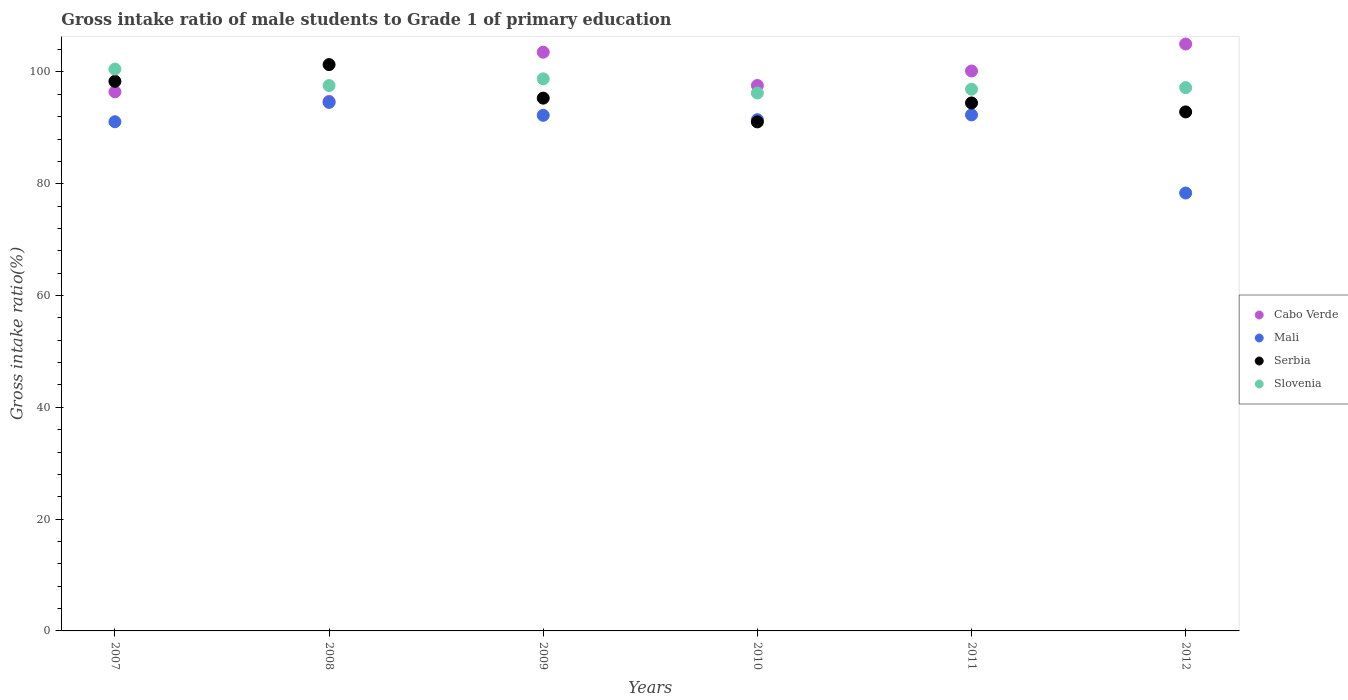How many different coloured dotlines are there?
Provide a short and direct response. 4. What is the gross intake ratio in Slovenia in 2012?
Your answer should be very brief. 97.2. Across all years, what is the maximum gross intake ratio in Slovenia?
Keep it short and to the point. 100.52. Across all years, what is the minimum gross intake ratio in Cabo Verde?
Provide a succinct answer. 94.73. In which year was the gross intake ratio in Serbia minimum?
Offer a terse response. 2010. What is the total gross intake ratio in Cabo Verde in the graph?
Offer a terse response. 597.49. What is the difference between the gross intake ratio in Mali in 2010 and that in 2012?
Ensure brevity in your answer.  13.12. What is the difference between the gross intake ratio in Serbia in 2008 and the gross intake ratio in Cabo Verde in 2010?
Keep it short and to the point. 3.73. What is the average gross intake ratio in Serbia per year?
Keep it short and to the point. 95.56. In the year 2011, what is the difference between the gross intake ratio in Mali and gross intake ratio in Cabo Verde?
Your answer should be very brief. -7.86. What is the ratio of the gross intake ratio in Cabo Verde in 2010 to that in 2011?
Ensure brevity in your answer.  0.97. Is the gross intake ratio in Slovenia in 2010 less than that in 2011?
Make the answer very short. Yes. Is the difference between the gross intake ratio in Mali in 2008 and 2012 greater than the difference between the gross intake ratio in Cabo Verde in 2008 and 2012?
Your answer should be very brief. Yes. What is the difference between the highest and the second highest gross intake ratio in Mali?
Provide a succinct answer. 2.24. What is the difference between the highest and the lowest gross intake ratio in Serbia?
Give a very brief answer. 10.25. In how many years, is the gross intake ratio in Slovenia greater than the average gross intake ratio in Slovenia taken over all years?
Your answer should be compact. 2. Is the sum of the gross intake ratio in Cabo Verde in 2007 and 2009 greater than the maximum gross intake ratio in Mali across all years?
Offer a terse response. Yes. Is it the case that in every year, the sum of the gross intake ratio in Serbia and gross intake ratio in Slovenia  is greater than the sum of gross intake ratio in Mali and gross intake ratio in Cabo Verde?
Keep it short and to the point. No. Is the gross intake ratio in Serbia strictly greater than the gross intake ratio in Cabo Verde over the years?
Provide a succinct answer. No. How many years are there in the graph?
Provide a short and direct response. 6. Are the values on the major ticks of Y-axis written in scientific E-notation?
Your answer should be compact. No. Does the graph contain any zero values?
Your answer should be very brief. No. Does the graph contain grids?
Your answer should be compact. No. Where does the legend appear in the graph?
Keep it short and to the point. Center right. How many legend labels are there?
Your answer should be compact. 4. What is the title of the graph?
Your answer should be compact. Gross intake ratio of male students to Grade 1 of primary education. Does "Upper middle income" appear as one of the legend labels in the graph?
Offer a terse response. No. What is the label or title of the X-axis?
Provide a short and direct response. Years. What is the label or title of the Y-axis?
Give a very brief answer. Gross intake ratio(%). What is the Gross intake ratio(%) of Cabo Verde in 2007?
Keep it short and to the point. 96.45. What is the Gross intake ratio(%) of Mali in 2007?
Ensure brevity in your answer.  91.1. What is the Gross intake ratio(%) of Serbia in 2007?
Provide a succinct answer. 98.33. What is the Gross intake ratio(%) of Slovenia in 2007?
Provide a succinct answer. 100.52. What is the Gross intake ratio(%) of Cabo Verde in 2008?
Provide a short and direct response. 94.73. What is the Gross intake ratio(%) in Mali in 2008?
Keep it short and to the point. 94.56. What is the Gross intake ratio(%) in Serbia in 2008?
Provide a succinct answer. 101.32. What is the Gross intake ratio(%) of Slovenia in 2008?
Your answer should be very brief. 97.57. What is the Gross intake ratio(%) in Cabo Verde in 2009?
Provide a short and direct response. 103.54. What is the Gross intake ratio(%) of Mali in 2009?
Offer a terse response. 92.24. What is the Gross intake ratio(%) of Serbia in 2009?
Keep it short and to the point. 95.32. What is the Gross intake ratio(%) of Slovenia in 2009?
Make the answer very short. 98.77. What is the Gross intake ratio(%) in Cabo Verde in 2010?
Offer a terse response. 97.59. What is the Gross intake ratio(%) of Mali in 2010?
Keep it short and to the point. 91.46. What is the Gross intake ratio(%) of Serbia in 2010?
Ensure brevity in your answer.  91.07. What is the Gross intake ratio(%) of Slovenia in 2010?
Give a very brief answer. 96.25. What is the Gross intake ratio(%) of Cabo Verde in 2011?
Ensure brevity in your answer.  100.18. What is the Gross intake ratio(%) of Mali in 2011?
Ensure brevity in your answer.  92.32. What is the Gross intake ratio(%) in Serbia in 2011?
Keep it short and to the point. 94.46. What is the Gross intake ratio(%) in Slovenia in 2011?
Make the answer very short. 96.91. What is the Gross intake ratio(%) in Cabo Verde in 2012?
Provide a short and direct response. 105. What is the Gross intake ratio(%) in Mali in 2012?
Give a very brief answer. 78.35. What is the Gross intake ratio(%) of Serbia in 2012?
Ensure brevity in your answer.  92.86. What is the Gross intake ratio(%) of Slovenia in 2012?
Offer a terse response. 97.2. Across all years, what is the maximum Gross intake ratio(%) of Cabo Verde?
Your response must be concise. 105. Across all years, what is the maximum Gross intake ratio(%) of Mali?
Keep it short and to the point. 94.56. Across all years, what is the maximum Gross intake ratio(%) of Serbia?
Offer a terse response. 101.32. Across all years, what is the maximum Gross intake ratio(%) in Slovenia?
Keep it short and to the point. 100.52. Across all years, what is the minimum Gross intake ratio(%) of Cabo Verde?
Provide a succinct answer. 94.73. Across all years, what is the minimum Gross intake ratio(%) in Mali?
Provide a short and direct response. 78.35. Across all years, what is the minimum Gross intake ratio(%) in Serbia?
Ensure brevity in your answer.  91.07. Across all years, what is the minimum Gross intake ratio(%) in Slovenia?
Your answer should be compact. 96.25. What is the total Gross intake ratio(%) in Cabo Verde in the graph?
Your answer should be compact. 597.49. What is the total Gross intake ratio(%) of Mali in the graph?
Provide a succinct answer. 540.04. What is the total Gross intake ratio(%) in Serbia in the graph?
Provide a succinct answer. 573.36. What is the total Gross intake ratio(%) of Slovenia in the graph?
Make the answer very short. 587.23. What is the difference between the Gross intake ratio(%) of Cabo Verde in 2007 and that in 2008?
Your answer should be very brief. 1.71. What is the difference between the Gross intake ratio(%) of Mali in 2007 and that in 2008?
Your answer should be compact. -3.46. What is the difference between the Gross intake ratio(%) in Serbia in 2007 and that in 2008?
Offer a terse response. -2.99. What is the difference between the Gross intake ratio(%) in Slovenia in 2007 and that in 2008?
Provide a short and direct response. 2.95. What is the difference between the Gross intake ratio(%) of Cabo Verde in 2007 and that in 2009?
Your answer should be compact. -7.09. What is the difference between the Gross intake ratio(%) of Mali in 2007 and that in 2009?
Your answer should be very brief. -1.14. What is the difference between the Gross intake ratio(%) in Serbia in 2007 and that in 2009?
Offer a very short reply. 3.01. What is the difference between the Gross intake ratio(%) of Slovenia in 2007 and that in 2009?
Keep it short and to the point. 1.74. What is the difference between the Gross intake ratio(%) in Cabo Verde in 2007 and that in 2010?
Provide a short and direct response. -1.14. What is the difference between the Gross intake ratio(%) of Mali in 2007 and that in 2010?
Ensure brevity in your answer.  -0.36. What is the difference between the Gross intake ratio(%) of Serbia in 2007 and that in 2010?
Offer a very short reply. 7.26. What is the difference between the Gross intake ratio(%) of Slovenia in 2007 and that in 2010?
Keep it short and to the point. 4.27. What is the difference between the Gross intake ratio(%) of Cabo Verde in 2007 and that in 2011?
Your response must be concise. -3.73. What is the difference between the Gross intake ratio(%) in Mali in 2007 and that in 2011?
Your answer should be very brief. -1.22. What is the difference between the Gross intake ratio(%) in Serbia in 2007 and that in 2011?
Your answer should be compact. 3.87. What is the difference between the Gross intake ratio(%) in Slovenia in 2007 and that in 2011?
Provide a short and direct response. 3.6. What is the difference between the Gross intake ratio(%) of Cabo Verde in 2007 and that in 2012?
Your answer should be compact. -8.55. What is the difference between the Gross intake ratio(%) in Mali in 2007 and that in 2012?
Provide a short and direct response. 12.75. What is the difference between the Gross intake ratio(%) of Serbia in 2007 and that in 2012?
Your response must be concise. 5.47. What is the difference between the Gross intake ratio(%) of Slovenia in 2007 and that in 2012?
Provide a succinct answer. 3.32. What is the difference between the Gross intake ratio(%) of Cabo Verde in 2008 and that in 2009?
Make the answer very short. -8.8. What is the difference between the Gross intake ratio(%) in Mali in 2008 and that in 2009?
Your answer should be very brief. 2.32. What is the difference between the Gross intake ratio(%) of Serbia in 2008 and that in 2009?
Provide a short and direct response. 6. What is the difference between the Gross intake ratio(%) in Slovenia in 2008 and that in 2009?
Ensure brevity in your answer.  -1.2. What is the difference between the Gross intake ratio(%) of Cabo Verde in 2008 and that in 2010?
Offer a terse response. -2.85. What is the difference between the Gross intake ratio(%) in Mali in 2008 and that in 2010?
Your answer should be very brief. 3.1. What is the difference between the Gross intake ratio(%) of Serbia in 2008 and that in 2010?
Your answer should be compact. 10.25. What is the difference between the Gross intake ratio(%) in Slovenia in 2008 and that in 2010?
Give a very brief answer. 1.32. What is the difference between the Gross intake ratio(%) of Cabo Verde in 2008 and that in 2011?
Offer a terse response. -5.45. What is the difference between the Gross intake ratio(%) of Mali in 2008 and that in 2011?
Ensure brevity in your answer.  2.24. What is the difference between the Gross intake ratio(%) in Serbia in 2008 and that in 2011?
Your answer should be compact. 6.86. What is the difference between the Gross intake ratio(%) of Slovenia in 2008 and that in 2011?
Make the answer very short. 0.66. What is the difference between the Gross intake ratio(%) of Cabo Verde in 2008 and that in 2012?
Your response must be concise. -10.27. What is the difference between the Gross intake ratio(%) of Mali in 2008 and that in 2012?
Your answer should be very brief. 16.21. What is the difference between the Gross intake ratio(%) of Serbia in 2008 and that in 2012?
Provide a succinct answer. 8.46. What is the difference between the Gross intake ratio(%) of Slovenia in 2008 and that in 2012?
Keep it short and to the point. 0.37. What is the difference between the Gross intake ratio(%) in Cabo Verde in 2009 and that in 2010?
Offer a very short reply. 5.95. What is the difference between the Gross intake ratio(%) in Mali in 2009 and that in 2010?
Your answer should be compact. 0.78. What is the difference between the Gross intake ratio(%) in Serbia in 2009 and that in 2010?
Provide a short and direct response. 4.25. What is the difference between the Gross intake ratio(%) in Slovenia in 2009 and that in 2010?
Provide a short and direct response. 2.53. What is the difference between the Gross intake ratio(%) of Cabo Verde in 2009 and that in 2011?
Give a very brief answer. 3.36. What is the difference between the Gross intake ratio(%) in Mali in 2009 and that in 2011?
Offer a terse response. -0.08. What is the difference between the Gross intake ratio(%) of Serbia in 2009 and that in 2011?
Provide a short and direct response. 0.86. What is the difference between the Gross intake ratio(%) of Slovenia in 2009 and that in 2011?
Give a very brief answer. 1.86. What is the difference between the Gross intake ratio(%) of Cabo Verde in 2009 and that in 2012?
Offer a very short reply. -1.47. What is the difference between the Gross intake ratio(%) in Mali in 2009 and that in 2012?
Make the answer very short. 13.9. What is the difference between the Gross intake ratio(%) of Serbia in 2009 and that in 2012?
Keep it short and to the point. 2.46. What is the difference between the Gross intake ratio(%) of Slovenia in 2009 and that in 2012?
Provide a short and direct response. 1.57. What is the difference between the Gross intake ratio(%) of Cabo Verde in 2010 and that in 2011?
Provide a succinct answer. -2.59. What is the difference between the Gross intake ratio(%) in Mali in 2010 and that in 2011?
Your answer should be compact. -0.86. What is the difference between the Gross intake ratio(%) in Serbia in 2010 and that in 2011?
Make the answer very short. -3.39. What is the difference between the Gross intake ratio(%) of Slovenia in 2010 and that in 2011?
Give a very brief answer. -0.67. What is the difference between the Gross intake ratio(%) of Cabo Verde in 2010 and that in 2012?
Provide a succinct answer. -7.42. What is the difference between the Gross intake ratio(%) of Mali in 2010 and that in 2012?
Your response must be concise. 13.12. What is the difference between the Gross intake ratio(%) of Serbia in 2010 and that in 2012?
Your answer should be compact. -1.79. What is the difference between the Gross intake ratio(%) of Slovenia in 2010 and that in 2012?
Your answer should be compact. -0.95. What is the difference between the Gross intake ratio(%) in Cabo Verde in 2011 and that in 2012?
Offer a terse response. -4.82. What is the difference between the Gross intake ratio(%) in Mali in 2011 and that in 2012?
Your answer should be compact. 13.98. What is the difference between the Gross intake ratio(%) in Serbia in 2011 and that in 2012?
Offer a very short reply. 1.6. What is the difference between the Gross intake ratio(%) of Slovenia in 2011 and that in 2012?
Your answer should be compact. -0.29. What is the difference between the Gross intake ratio(%) of Cabo Verde in 2007 and the Gross intake ratio(%) of Mali in 2008?
Keep it short and to the point. 1.89. What is the difference between the Gross intake ratio(%) in Cabo Verde in 2007 and the Gross intake ratio(%) in Serbia in 2008?
Give a very brief answer. -4.87. What is the difference between the Gross intake ratio(%) in Cabo Verde in 2007 and the Gross intake ratio(%) in Slovenia in 2008?
Provide a succinct answer. -1.12. What is the difference between the Gross intake ratio(%) of Mali in 2007 and the Gross intake ratio(%) of Serbia in 2008?
Make the answer very short. -10.22. What is the difference between the Gross intake ratio(%) of Mali in 2007 and the Gross intake ratio(%) of Slovenia in 2008?
Give a very brief answer. -6.47. What is the difference between the Gross intake ratio(%) of Serbia in 2007 and the Gross intake ratio(%) of Slovenia in 2008?
Give a very brief answer. 0.76. What is the difference between the Gross intake ratio(%) in Cabo Verde in 2007 and the Gross intake ratio(%) in Mali in 2009?
Keep it short and to the point. 4.2. What is the difference between the Gross intake ratio(%) of Cabo Verde in 2007 and the Gross intake ratio(%) of Serbia in 2009?
Ensure brevity in your answer.  1.13. What is the difference between the Gross intake ratio(%) of Cabo Verde in 2007 and the Gross intake ratio(%) of Slovenia in 2009?
Make the answer very short. -2.33. What is the difference between the Gross intake ratio(%) in Mali in 2007 and the Gross intake ratio(%) in Serbia in 2009?
Offer a very short reply. -4.22. What is the difference between the Gross intake ratio(%) in Mali in 2007 and the Gross intake ratio(%) in Slovenia in 2009?
Ensure brevity in your answer.  -7.67. What is the difference between the Gross intake ratio(%) of Serbia in 2007 and the Gross intake ratio(%) of Slovenia in 2009?
Offer a very short reply. -0.45. What is the difference between the Gross intake ratio(%) of Cabo Verde in 2007 and the Gross intake ratio(%) of Mali in 2010?
Keep it short and to the point. 4.99. What is the difference between the Gross intake ratio(%) in Cabo Verde in 2007 and the Gross intake ratio(%) in Serbia in 2010?
Your answer should be compact. 5.38. What is the difference between the Gross intake ratio(%) in Cabo Verde in 2007 and the Gross intake ratio(%) in Slovenia in 2010?
Your response must be concise. 0.2. What is the difference between the Gross intake ratio(%) in Mali in 2007 and the Gross intake ratio(%) in Serbia in 2010?
Your answer should be very brief. 0.03. What is the difference between the Gross intake ratio(%) of Mali in 2007 and the Gross intake ratio(%) of Slovenia in 2010?
Your answer should be compact. -5.15. What is the difference between the Gross intake ratio(%) in Serbia in 2007 and the Gross intake ratio(%) in Slovenia in 2010?
Keep it short and to the point. 2.08. What is the difference between the Gross intake ratio(%) of Cabo Verde in 2007 and the Gross intake ratio(%) of Mali in 2011?
Your response must be concise. 4.12. What is the difference between the Gross intake ratio(%) in Cabo Verde in 2007 and the Gross intake ratio(%) in Serbia in 2011?
Your answer should be compact. 1.99. What is the difference between the Gross intake ratio(%) in Cabo Verde in 2007 and the Gross intake ratio(%) in Slovenia in 2011?
Your answer should be compact. -0.47. What is the difference between the Gross intake ratio(%) in Mali in 2007 and the Gross intake ratio(%) in Serbia in 2011?
Give a very brief answer. -3.36. What is the difference between the Gross intake ratio(%) of Mali in 2007 and the Gross intake ratio(%) of Slovenia in 2011?
Your response must be concise. -5.81. What is the difference between the Gross intake ratio(%) in Serbia in 2007 and the Gross intake ratio(%) in Slovenia in 2011?
Your answer should be compact. 1.41. What is the difference between the Gross intake ratio(%) of Cabo Verde in 2007 and the Gross intake ratio(%) of Mali in 2012?
Provide a succinct answer. 18.1. What is the difference between the Gross intake ratio(%) of Cabo Verde in 2007 and the Gross intake ratio(%) of Serbia in 2012?
Give a very brief answer. 3.59. What is the difference between the Gross intake ratio(%) in Cabo Verde in 2007 and the Gross intake ratio(%) in Slovenia in 2012?
Offer a very short reply. -0.75. What is the difference between the Gross intake ratio(%) in Mali in 2007 and the Gross intake ratio(%) in Serbia in 2012?
Provide a succinct answer. -1.76. What is the difference between the Gross intake ratio(%) of Mali in 2007 and the Gross intake ratio(%) of Slovenia in 2012?
Give a very brief answer. -6.1. What is the difference between the Gross intake ratio(%) in Serbia in 2007 and the Gross intake ratio(%) in Slovenia in 2012?
Offer a very short reply. 1.13. What is the difference between the Gross intake ratio(%) of Cabo Verde in 2008 and the Gross intake ratio(%) of Mali in 2009?
Your answer should be very brief. 2.49. What is the difference between the Gross intake ratio(%) in Cabo Verde in 2008 and the Gross intake ratio(%) in Serbia in 2009?
Provide a succinct answer. -0.59. What is the difference between the Gross intake ratio(%) of Cabo Verde in 2008 and the Gross intake ratio(%) of Slovenia in 2009?
Your answer should be very brief. -4.04. What is the difference between the Gross intake ratio(%) in Mali in 2008 and the Gross intake ratio(%) in Serbia in 2009?
Keep it short and to the point. -0.76. What is the difference between the Gross intake ratio(%) in Mali in 2008 and the Gross intake ratio(%) in Slovenia in 2009?
Make the answer very short. -4.21. What is the difference between the Gross intake ratio(%) of Serbia in 2008 and the Gross intake ratio(%) of Slovenia in 2009?
Keep it short and to the point. 2.55. What is the difference between the Gross intake ratio(%) in Cabo Verde in 2008 and the Gross intake ratio(%) in Mali in 2010?
Give a very brief answer. 3.27. What is the difference between the Gross intake ratio(%) in Cabo Verde in 2008 and the Gross intake ratio(%) in Serbia in 2010?
Keep it short and to the point. 3.66. What is the difference between the Gross intake ratio(%) of Cabo Verde in 2008 and the Gross intake ratio(%) of Slovenia in 2010?
Your answer should be compact. -1.51. What is the difference between the Gross intake ratio(%) in Mali in 2008 and the Gross intake ratio(%) in Serbia in 2010?
Provide a short and direct response. 3.49. What is the difference between the Gross intake ratio(%) of Mali in 2008 and the Gross intake ratio(%) of Slovenia in 2010?
Offer a terse response. -1.69. What is the difference between the Gross intake ratio(%) in Serbia in 2008 and the Gross intake ratio(%) in Slovenia in 2010?
Give a very brief answer. 5.07. What is the difference between the Gross intake ratio(%) of Cabo Verde in 2008 and the Gross intake ratio(%) of Mali in 2011?
Your response must be concise. 2.41. What is the difference between the Gross intake ratio(%) of Cabo Verde in 2008 and the Gross intake ratio(%) of Serbia in 2011?
Make the answer very short. 0.27. What is the difference between the Gross intake ratio(%) of Cabo Verde in 2008 and the Gross intake ratio(%) of Slovenia in 2011?
Provide a succinct answer. -2.18. What is the difference between the Gross intake ratio(%) of Mali in 2008 and the Gross intake ratio(%) of Serbia in 2011?
Keep it short and to the point. 0.1. What is the difference between the Gross intake ratio(%) in Mali in 2008 and the Gross intake ratio(%) in Slovenia in 2011?
Ensure brevity in your answer.  -2.35. What is the difference between the Gross intake ratio(%) of Serbia in 2008 and the Gross intake ratio(%) of Slovenia in 2011?
Your response must be concise. 4.41. What is the difference between the Gross intake ratio(%) of Cabo Verde in 2008 and the Gross intake ratio(%) of Mali in 2012?
Ensure brevity in your answer.  16.39. What is the difference between the Gross intake ratio(%) of Cabo Verde in 2008 and the Gross intake ratio(%) of Serbia in 2012?
Keep it short and to the point. 1.88. What is the difference between the Gross intake ratio(%) of Cabo Verde in 2008 and the Gross intake ratio(%) of Slovenia in 2012?
Your response must be concise. -2.47. What is the difference between the Gross intake ratio(%) in Mali in 2008 and the Gross intake ratio(%) in Serbia in 2012?
Ensure brevity in your answer.  1.7. What is the difference between the Gross intake ratio(%) in Mali in 2008 and the Gross intake ratio(%) in Slovenia in 2012?
Make the answer very short. -2.64. What is the difference between the Gross intake ratio(%) of Serbia in 2008 and the Gross intake ratio(%) of Slovenia in 2012?
Offer a terse response. 4.12. What is the difference between the Gross intake ratio(%) of Cabo Verde in 2009 and the Gross intake ratio(%) of Mali in 2010?
Offer a very short reply. 12.07. What is the difference between the Gross intake ratio(%) of Cabo Verde in 2009 and the Gross intake ratio(%) of Serbia in 2010?
Your response must be concise. 12.47. What is the difference between the Gross intake ratio(%) of Cabo Verde in 2009 and the Gross intake ratio(%) of Slovenia in 2010?
Give a very brief answer. 7.29. What is the difference between the Gross intake ratio(%) of Mali in 2009 and the Gross intake ratio(%) of Serbia in 2010?
Offer a very short reply. 1.17. What is the difference between the Gross intake ratio(%) in Mali in 2009 and the Gross intake ratio(%) in Slovenia in 2010?
Ensure brevity in your answer.  -4. What is the difference between the Gross intake ratio(%) in Serbia in 2009 and the Gross intake ratio(%) in Slovenia in 2010?
Ensure brevity in your answer.  -0.93. What is the difference between the Gross intake ratio(%) of Cabo Verde in 2009 and the Gross intake ratio(%) of Mali in 2011?
Offer a terse response. 11.21. What is the difference between the Gross intake ratio(%) in Cabo Verde in 2009 and the Gross intake ratio(%) in Serbia in 2011?
Make the answer very short. 9.08. What is the difference between the Gross intake ratio(%) in Cabo Verde in 2009 and the Gross intake ratio(%) in Slovenia in 2011?
Offer a terse response. 6.62. What is the difference between the Gross intake ratio(%) in Mali in 2009 and the Gross intake ratio(%) in Serbia in 2011?
Offer a very short reply. -2.22. What is the difference between the Gross intake ratio(%) of Mali in 2009 and the Gross intake ratio(%) of Slovenia in 2011?
Your answer should be compact. -4.67. What is the difference between the Gross intake ratio(%) in Serbia in 2009 and the Gross intake ratio(%) in Slovenia in 2011?
Your answer should be very brief. -1.59. What is the difference between the Gross intake ratio(%) in Cabo Verde in 2009 and the Gross intake ratio(%) in Mali in 2012?
Offer a terse response. 25.19. What is the difference between the Gross intake ratio(%) of Cabo Verde in 2009 and the Gross intake ratio(%) of Serbia in 2012?
Your response must be concise. 10.68. What is the difference between the Gross intake ratio(%) in Cabo Verde in 2009 and the Gross intake ratio(%) in Slovenia in 2012?
Your answer should be compact. 6.34. What is the difference between the Gross intake ratio(%) in Mali in 2009 and the Gross intake ratio(%) in Serbia in 2012?
Give a very brief answer. -0.61. What is the difference between the Gross intake ratio(%) of Mali in 2009 and the Gross intake ratio(%) of Slovenia in 2012?
Provide a short and direct response. -4.96. What is the difference between the Gross intake ratio(%) of Serbia in 2009 and the Gross intake ratio(%) of Slovenia in 2012?
Provide a short and direct response. -1.88. What is the difference between the Gross intake ratio(%) in Cabo Verde in 2010 and the Gross intake ratio(%) in Mali in 2011?
Your response must be concise. 5.26. What is the difference between the Gross intake ratio(%) in Cabo Verde in 2010 and the Gross intake ratio(%) in Serbia in 2011?
Give a very brief answer. 3.13. What is the difference between the Gross intake ratio(%) in Cabo Verde in 2010 and the Gross intake ratio(%) in Slovenia in 2011?
Offer a terse response. 0.67. What is the difference between the Gross intake ratio(%) in Mali in 2010 and the Gross intake ratio(%) in Serbia in 2011?
Offer a very short reply. -3. What is the difference between the Gross intake ratio(%) in Mali in 2010 and the Gross intake ratio(%) in Slovenia in 2011?
Your response must be concise. -5.45. What is the difference between the Gross intake ratio(%) in Serbia in 2010 and the Gross intake ratio(%) in Slovenia in 2011?
Offer a very short reply. -5.84. What is the difference between the Gross intake ratio(%) in Cabo Verde in 2010 and the Gross intake ratio(%) in Mali in 2012?
Your answer should be compact. 19.24. What is the difference between the Gross intake ratio(%) of Cabo Verde in 2010 and the Gross intake ratio(%) of Serbia in 2012?
Offer a very short reply. 4.73. What is the difference between the Gross intake ratio(%) in Cabo Verde in 2010 and the Gross intake ratio(%) in Slovenia in 2012?
Provide a succinct answer. 0.39. What is the difference between the Gross intake ratio(%) of Mali in 2010 and the Gross intake ratio(%) of Serbia in 2012?
Give a very brief answer. -1.39. What is the difference between the Gross intake ratio(%) of Mali in 2010 and the Gross intake ratio(%) of Slovenia in 2012?
Provide a succinct answer. -5.74. What is the difference between the Gross intake ratio(%) of Serbia in 2010 and the Gross intake ratio(%) of Slovenia in 2012?
Your answer should be very brief. -6.13. What is the difference between the Gross intake ratio(%) in Cabo Verde in 2011 and the Gross intake ratio(%) in Mali in 2012?
Ensure brevity in your answer.  21.83. What is the difference between the Gross intake ratio(%) of Cabo Verde in 2011 and the Gross intake ratio(%) of Serbia in 2012?
Your answer should be very brief. 7.32. What is the difference between the Gross intake ratio(%) of Cabo Verde in 2011 and the Gross intake ratio(%) of Slovenia in 2012?
Provide a succinct answer. 2.98. What is the difference between the Gross intake ratio(%) in Mali in 2011 and the Gross intake ratio(%) in Serbia in 2012?
Your answer should be compact. -0.53. What is the difference between the Gross intake ratio(%) in Mali in 2011 and the Gross intake ratio(%) in Slovenia in 2012?
Ensure brevity in your answer.  -4.88. What is the difference between the Gross intake ratio(%) of Serbia in 2011 and the Gross intake ratio(%) of Slovenia in 2012?
Ensure brevity in your answer.  -2.74. What is the average Gross intake ratio(%) of Cabo Verde per year?
Your response must be concise. 99.58. What is the average Gross intake ratio(%) in Mali per year?
Keep it short and to the point. 90.01. What is the average Gross intake ratio(%) in Serbia per year?
Provide a short and direct response. 95.56. What is the average Gross intake ratio(%) of Slovenia per year?
Offer a very short reply. 97.87. In the year 2007, what is the difference between the Gross intake ratio(%) of Cabo Verde and Gross intake ratio(%) of Mali?
Your answer should be compact. 5.35. In the year 2007, what is the difference between the Gross intake ratio(%) of Cabo Verde and Gross intake ratio(%) of Serbia?
Your response must be concise. -1.88. In the year 2007, what is the difference between the Gross intake ratio(%) in Cabo Verde and Gross intake ratio(%) in Slovenia?
Give a very brief answer. -4.07. In the year 2007, what is the difference between the Gross intake ratio(%) in Mali and Gross intake ratio(%) in Serbia?
Your answer should be compact. -7.23. In the year 2007, what is the difference between the Gross intake ratio(%) in Mali and Gross intake ratio(%) in Slovenia?
Give a very brief answer. -9.42. In the year 2007, what is the difference between the Gross intake ratio(%) of Serbia and Gross intake ratio(%) of Slovenia?
Your response must be concise. -2.19. In the year 2008, what is the difference between the Gross intake ratio(%) in Cabo Verde and Gross intake ratio(%) in Mali?
Provide a short and direct response. 0.17. In the year 2008, what is the difference between the Gross intake ratio(%) of Cabo Verde and Gross intake ratio(%) of Serbia?
Your answer should be compact. -6.59. In the year 2008, what is the difference between the Gross intake ratio(%) in Cabo Verde and Gross intake ratio(%) in Slovenia?
Your answer should be compact. -2.84. In the year 2008, what is the difference between the Gross intake ratio(%) of Mali and Gross intake ratio(%) of Serbia?
Offer a terse response. -6.76. In the year 2008, what is the difference between the Gross intake ratio(%) in Mali and Gross intake ratio(%) in Slovenia?
Your answer should be very brief. -3.01. In the year 2008, what is the difference between the Gross intake ratio(%) of Serbia and Gross intake ratio(%) of Slovenia?
Your response must be concise. 3.75. In the year 2009, what is the difference between the Gross intake ratio(%) in Cabo Verde and Gross intake ratio(%) in Mali?
Provide a succinct answer. 11.29. In the year 2009, what is the difference between the Gross intake ratio(%) in Cabo Verde and Gross intake ratio(%) in Serbia?
Give a very brief answer. 8.22. In the year 2009, what is the difference between the Gross intake ratio(%) of Cabo Verde and Gross intake ratio(%) of Slovenia?
Provide a short and direct response. 4.76. In the year 2009, what is the difference between the Gross intake ratio(%) in Mali and Gross intake ratio(%) in Serbia?
Provide a succinct answer. -3.08. In the year 2009, what is the difference between the Gross intake ratio(%) in Mali and Gross intake ratio(%) in Slovenia?
Offer a very short reply. -6.53. In the year 2009, what is the difference between the Gross intake ratio(%) in Serbia and Gross intake ratio(%) in Slovenia?
Offer a terse response. -3.45. In the year 2010, what is the difference between the Gross intake ratio(%) of Cabo Verde and Gross intake ratio(%) of Mali?
Make the answer very short. 6.12. In the year 2010, what is the difference between the Gross intake ratio(%) in Cabo Verde and Gross intake ratio(%) in Serbia?
Keep it short and to the point. 6.52. In the year 2010, what is the difference between the Gross intake ratio(%) in Cabo Verde and Gross intake ratio(%) in Slovenia?
Your response must be concise. 1.34. In the year 2010, what is the difference between the Gross intake ratio(%) of Mali and Gross intake ratio(%) of Serbia?
Offer a very short reply. 0.39. In the year 2010, what is the difference between the Gross intake ratio(%) in Mali and Gross intake ratio(%) in Slovenia?
Offer a very short reply. -4.78. In the year 2010, what is the difference between the Gross intake ratio(%) in Serbia and Gross intake ratio(%) in Slovenia?
Your response must be concise. -5.17. In the year 2011, what is the difference between the Gross intake ratio(%) in Cabo Verde and Gross intake ratio(%) in Mali?
Give a very brief answer. 7.86. In the year 2011, what is the difference between the Gross intake ratio(%) in Cabo Verde and Gross intake ratio(%) in Serbia?
Give a very brief answer. 5.72. In the year 2011, what is the difference between the Gross intake ratio(%) of Cabo Verde and Gross intake ratio(%) of Slovenia?
Your response must be concise. 3.27. In the year 2011, what is the difference between the Gross intake ratio(%) in Mali and Gross intake ratio(%) in Serbia?
Provide a succinct answer. -2.14. In the year 2011, what is the difference between the Gross intake ratio(%) of Mali and Gross intake ratio(%) of Slovenia?
Offer a terse response. -4.59. In the year 2011, what is the difference between the Gross intake ratio(%) in Serbia and Gross intake ratio(%) in Slovenia?
Keep it short and to the point. -2.45. In the year 2012, what is the difference between the Gross intake ratio(%) of Cabo Verde and Gross intake ratio(%) of Mali?
Give a very brief answer. 26.66. In the year 2012, what is the difference between the Gross intake ratio(%) in Cabo Verde and Gross intake ratio(%) in Serbia?
Your response must be concise. 12.15. In the year 2012, what is the difference between the Gross intake ratio(%) of Cabo Verde and Gross intake ratio(%) of Slovenia?
Keep it short and to the point. 7.8. In the year 2012, what is the difference between the Gross intake ratio(%) in Mali and Gross intake ratio(%) in Serbia?
Make the answer very short. -14.51. In the year 2012, what is the difference between the Gross intake ratio(%) of Mali and Gross intake ratio(%) of Slovenia?
Offer a terse response. -18.85. In the year 2012, what is the difference between the Gross intake ratio(%) in Serbia and Gross intake ratio(%) in Slovenia?
Offer a very short reply. -4.34. What is the ratio of the Gross intake ratio(%) of Cabo Verde in 2007 to that in 2008?
Offer a very short reply. 1.02. What is the ratio of the Gross intake ratio(%) of Mali in 2007 to that in 2008?
Offer a terse response. 0.96. What is the ratio of the Gross intake ratio(%) of Serbia in 2007 to that in 2008?
Make the answer very short. 0.97. What is the ratio of the Gross intake ratio(%) of Slovenia in 2007 to that in 2008?
Offer a terse response. 1.03. What is the ratio of the Gross intake ratio(%) in Cabo Verde in 2007 to that in 2009?
Ensure brevity in your answer.  0.93. What is the ratio of the Gross intake ratio(%) of Mali in 2007 to that in 2009?
Provide a short and direct response. 0.99. What is the ratio of the Gross intake ratio(%) in Serbia in 2007 to that in 2009?
Offer a very short reply. 1.03. What is the ratio of the Gross intake ratio(%) in Slovenia in 2007 to that in 2009?
Offer a terse response. 1.02. What is the ratio of the Gross intake ratio(%) of Cabo Verde in 2007 to that in 2010?
Ensure brevity in your answer.  0.99. What is the ratio of the Gross intake ratio(%) of Serbia in 2007 to that in 2010?
Ensure brevity in your answer.  1.08. What is the ratio of the Gross intake ratio(%) of Slovenia in 2007 to that in 2010?
Your response must be concise. 1.04. What is the ratio of the Gross intake ratio(%) of Cabo Verde in 2007 to that in 2011?
Offer a terse response. 0.96. What is the ratio of the Gross intake ratio(%) in Mali in 2007 to that in 2011?
Keep it short and to the point. 0.99. What is the ratio of the Gross intake ratio(%) of Serbia in 2007 to that in 2011?
Offer a terse response. 1.04. What is the ratio of the Gross intake ratio(%) of Slovenia in 2007 to that in 2011?
Provide a succinct answer. 1.04. What is the ratio of the Gross intake ratio(%) in Cabo Verde in 2007 to that in 2012?
Offer a very short reply. 0.92. What is the ratio of the Gross intake ratio(%) in Mali in 2007 to that in 2012?
Ensure brevity in your answer.  1.16. What is the ratio of the Gross intake ratio(%) of Serbia in 2007 to that in 2012?
Offer a terse response. 1.06. What is the ratio of the Gross intake ratio(%) in Slovenia in 2007 to that in 2012?
Provide a short and direct response. 1.03. What is the ratio of the Gross intake ratio(%) in Cabo Verde in 2008 to that in 2009?
Provide a short and direct response. 0.92. What is the ratio of the Gross intake ratio(%) in Mali in 2008 to that in 2009?
Your answer should be very brief. 1.03. What is the ratio of the Gross intake ratio(%) of Serbia in 2008 to that in 2009?
Keep it short and to the point. 1.06. What is the ratio of the Gross intake ratio(%) in Slovenia in 2008 to that in 2009?
Offer a terse response. 0.99. What is the ratio of the Gross intake ratio(%) in Cabo Verde in 2008 to that in 2010?
Your answer should be very brief. 0.97. What is the ratio of the Gross intake ratio(%) of Mali in 2008 to that in 2010?
Offer a very short reply. 1.03. What is the ratio of the Gross intake ratio(%) of Serbia in 2008 to that in 2010?
Give a very brief answer. 1.11. What is the ratio of the Gross intake ratio(%) of Slovenia in 2008 to that in 2010?
Make the answer very short. 1.01. What is the ratio of the Gross intake ratio(%) in Cabo Verde in 2008 to that in 2011?
Give a very brief answer. 0.95. What is the ratio of the Gross intake ratio(%) in Mali in 2008 to that in 2011?
Provide a short and direct response. 1.02. What is the ratio of the Gross intake ratio(%) of Serbia in 2008 to that in 2011?
Your answer should be compact. 1.07. What is the ratio of the Gross intake ratio(%) in Slovenia in 2008 to that in 2011?
Offer a terse response. 1.01. What is the ratio of the Gross intake ratio(%) in Cabo Verde in 2008 to that in 2012?
Make the answer very short. 0.9. What is the ratio of the Gross intake ratio(%) in Mali in 2008 to that in 2012?
Provide a succinct answer. 1.21. What is the ratio of the Gross intake ratio(%) of Serbia in 2008 to that in 2012?
Offer a very short reply. 1.09. What is the ratio of the Gross intake ratio(%) in Cabo Verde in 2009 to that in 2010?
Give a very brief answer. 1.06. What is the ratio of the Gross intake ratio(%) in Mali in 2009 to that in 2010?
Your response must be concise. 1.01. What is the ratio of the Gross intake ratio(%) of Serbia in 2009 to that in 2010?
Offer a terse response. 1.05. What is the ratio of the Gross intake ratio(%) of Slovenia in 2009 to that in 2010?
Keep it short and to the point. 1.03. What is the ratio of the Gross intake ratio(%) in Cabo Verde in 2009 to that in 2011?
Your answer should be very brief. 1.03. What is the ratio of the Gross intake ratio(%) in Serbia in 2009 to that in 2011?
Provide a short and direct response. 1.01. What is the ratio of the Gross intake ratio(%) in Slovenia in 2009 to that in 2011?
Ensure brevity in your answer.  1.02. What is the ratio of the Gross intake ratio(%) in Cabo Verde in 2009 to that in 2012?
Offer a terse response. 0.99. What is the ratio of the Gross intake ratio(%) of Mali in 2009 to that in 2012?
Ensure brevity in your answer.  1.18. What is the ratio of the Gross intake ratio(%) of Serbia in 2009 to that in 2012?
Your answer should be very brief. 1.03. What is the ratio of the Gross intake ratio(%) of Slovenia in 2009 to that in 2012?
Your answer should be very brief. 1.02. What is the ratio of the Gross intake ratio(%) of Cabo Verde in 2010 to that in 2011?
Provide a short and direct response. 0.97. What is the ratio of the Gross intake ratio(%) of Serbia in 2010 to that in 2011?
Make the answer very short. 0.96. What is the ratio of the Gross intake ratio(%) in Slovenia in 2010 to that in 2011?
Ensure brevity in your answer.  0.99. What is the ratio of the Gross intake ratio(%) of Cabo Verde in 2010 to that in 2012?
Your answer should be compact. 0.93. What is the ratio of the Gross intake ratio(%) in Mali in 2010 to that in 2012?
Offer a terse response. 1.17. What is the ratio of the Gross intake ratio(%) in Serbia in 2010 to that in 2012?
Give a very brief answer. 0.98. What is the ratio of the Gross intake ratio(%) in Slovenia in 2010 to that in 2012?
Your response must be concise. 0.99. What is the ratio of the Gross intake ratio(%) in Cabo Verde in 2011 to that in 2012?
Offer a very short reply. 0.95. What is the ratio of the Gross intake ratio(%) of Mali in 2011 to that in 2012?
Keep it short and to the point. 1.18. What is the ratio of the Gross intake ratio(%) in Serbia in 2011 to that in 2012?
Your response must be concise. 1.02. What is the difference between the highest and the second highest Gross intake ratio(%) in Cabo Verde?
Your response must be concise. 1.47. What is the difference between the highest and the second highest Gross intake ratio(%) in Mali?
Provide a short and direct response. 2.24. What is the difference between the highest and the second highest Gross intake ratio(%) in Serbia?
Keep it short and to the point. 2.99. What is the difference between the highest and the second highest Gross intake ratio(%) of Slovenia?
Your answer should be compact. 1.74. What is the difference between the highest and the lowest Gross intake ratio(%) of Cabo Verde?
Ensure brevity in your answer.  10.27. What is the difference between the highest and the lowest Gross intake ratio(%) in Mali?
Make the answer very short. 16.21. What is the difference between the highest and the lowest Gross intake ratio(%) in Serbia?
Make the answer very short. 10.25. What is the difference between the highest and the lowest Gross intake ratio(%) of Slovenia?
Offer a terse response. 4.27. 